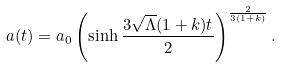Convert formula to latex. <formula><loc_0><loc_0><loc_500><loc_500>a ( t ) = a _ { 0 } \left ( \sinh \frac { 3 \sqrt { \Lambda } ( 1 + k ) t } { 2 } \right ) ^ { \frac { 2 } { 3 ( 1 + k ) } } .</formula> 